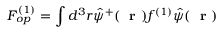Convert formula to latex. <formula><loc_0><loc_0><loc_500><loc_500>F _ { o p } ^ { ( 1 ) } = \int d ^ { 3 } r \hat { \psi } ^ { + } ( r ) f ^ { ( 1 ) } \hat { \psi } ( r )</formula> 